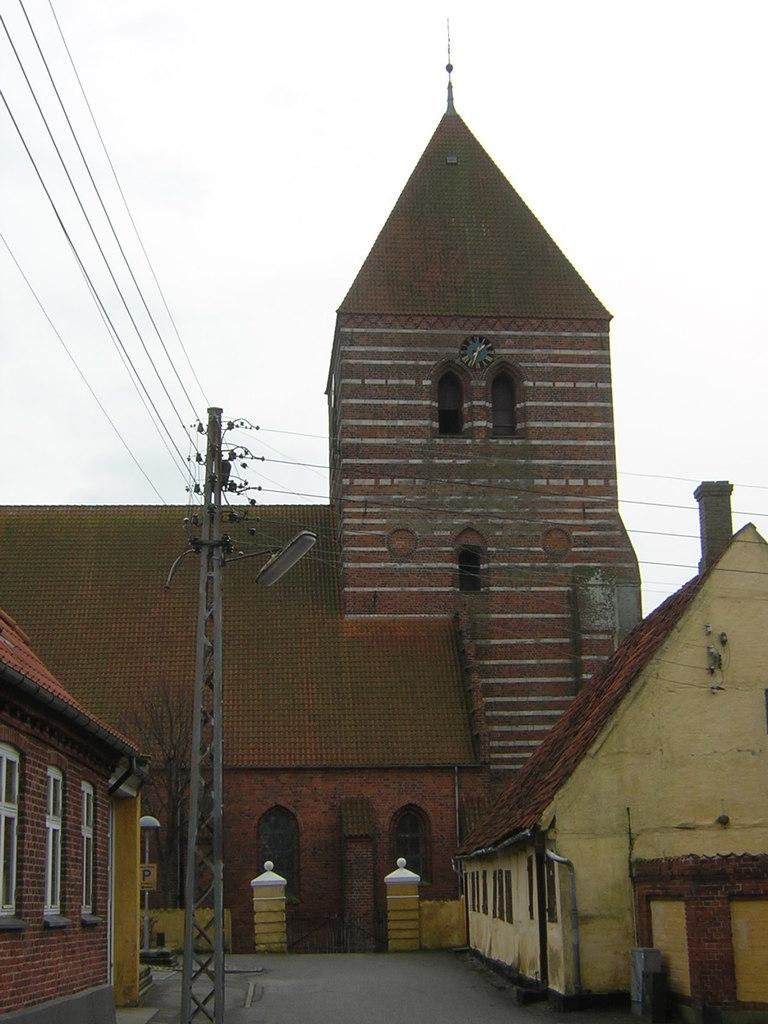What can be seen in the background of the image? The sky is visible in the background of the image. What type of structure is present in the image? There is a building in the image. What type of residential structures are present in the image? There are houses in the image. What architectural features can be seen in the image? There are windows and poles in the image. What utility infrastructure is present in the image? Transmission wires are present in the image. What type of pathway is visible in the image? There is a pathway in the image. What other unspecified objects are present in the image? There are a few unspecified objects in the image. What type of orange is being used as a canvas for an art piece in the image? There is no orange or art piece present in the image. What advice is being given to the person in the image? There is no person or advice being given in the image. 